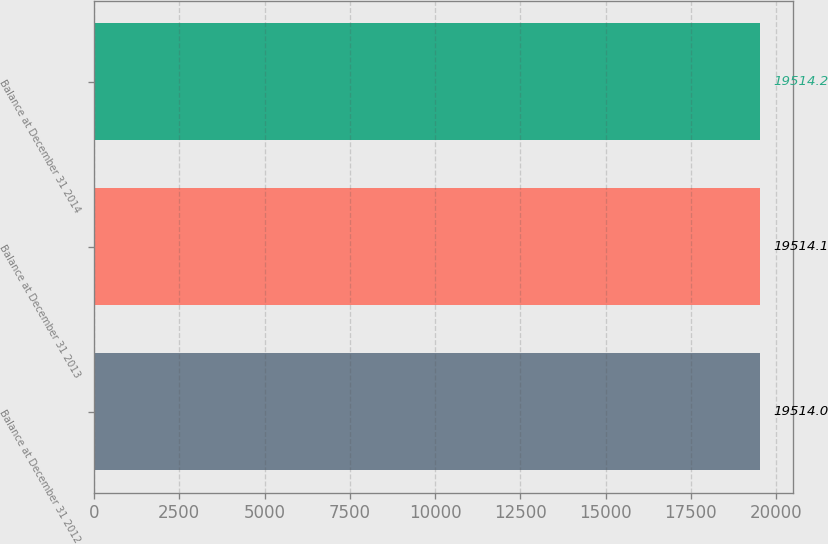Convert chart to OTSL. <chart><loc_0><loc_0><loc_500><loc_500><bar_chart><fcel>Balance at December 31 2012<fcel>Balance at December 31 2013<fcel>Balance at December 31 2014<nl><fcel>19514<fcel>19514.1<fcel>19514.2<nl></chart> 